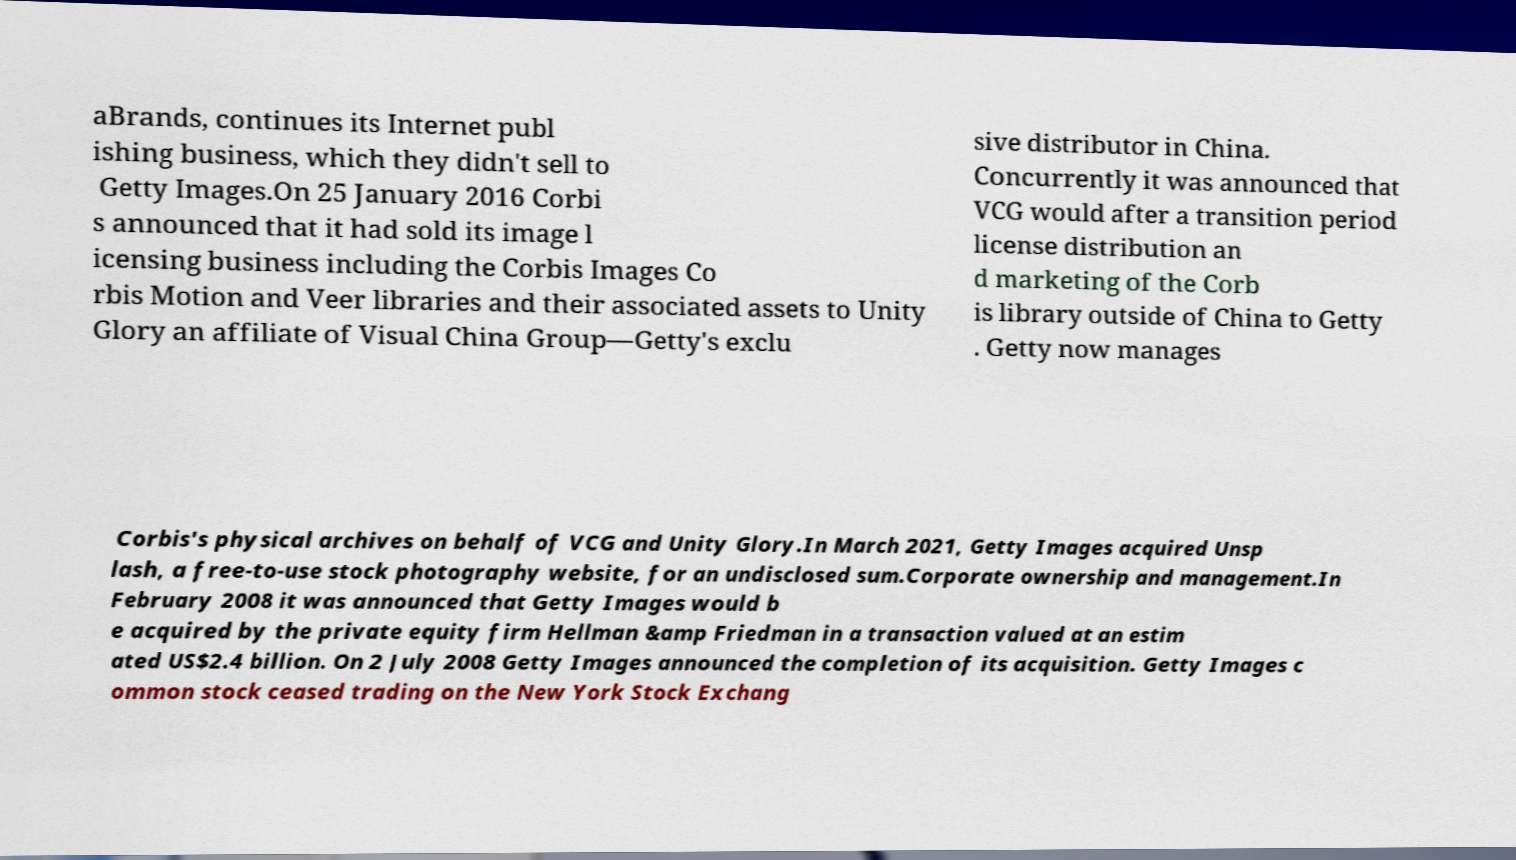Can you read and provide the text displayed in the image?This photo seems to have some interesting text. Can you extract and type it out for me? aBrands, continues its Internet publ ishing business, which they didn't sell to Getty Images.On 25 January 2016 Corbi s announced that it had sold its image l icensing business including the Corbis Images Co rbis Motion and Veer libraries and their associated assets to Unity Glory an affiliate of Visual China Group—Getty's exclu sive distributor in China. Concurrently it was announced that VCG would after a transition period license distribution an d marketing of the Corb is library outside of China to Getty . Getty now manages Corbis's physical archives on behalf of VCG and Unity Glory.In March 2021, Getty Images acquired Unsp lash, a free-to-use stock photography website, for an undisclosed sum.Corporate ownership and management.In February 2008 it was announced that Getty Images would b e acquired by the private equity firm Hellman &amp Friedman in a transaction valued at an estim ated US$2.4 billion. On 2 July 2008 Getty Images announced the completion of its acquisition. Getty Images c ommon stock ceased trading on the New York Stock Exchang 